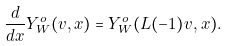<formula> <loc_0><loc_0><loc_500><loc_500>\frac { d } { d x } Y ^ { o } _ { W } ( v , x ) = Y ^ { o } _ { W } ( L ( - 1 ) v , x ) .</formula> 